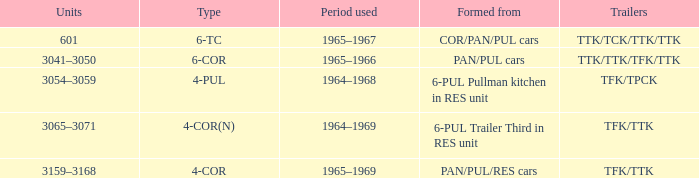Identify the trailers made out of pan/pul/res cars. TFK/TTK. 